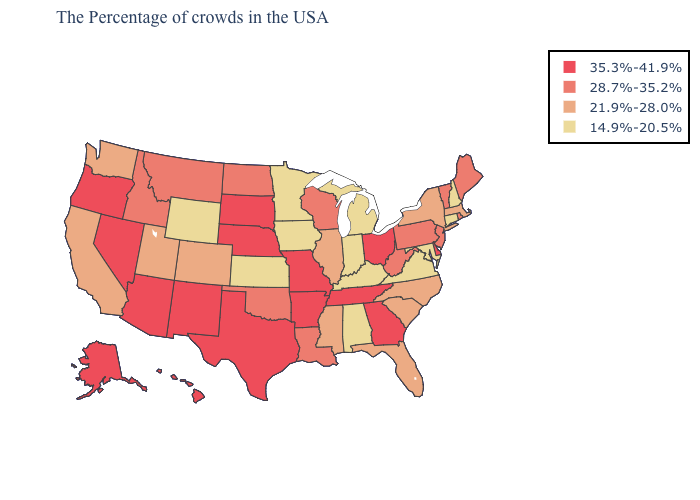Does Hawaii have the lowest value in the USA?
Write a very short answer. No. What is the value of Oklahoma?
Short answer required. 28.7%-35.2%. Does the first symbol in the legend represent the smallest category?
Concise answer only. No. What is the highest value in the USA?
Quick response, please. 35.3%-41.9%. Does Virginia have the lowest value in the USA?
Answer briefly. Yes. Among the states that border West Virginia , does Ohio have the highest value?
Short answer required. Yes. Does Wyoming have the lowest value in the West?
Keep it brief. Yes. Among the states that border South Carolina , does North Carolina have the lowest value?
Write a very short answer. Yes. What is the highest value in the USA?
Be succinct. 35.3%-41.9%. What is the highest value in the USA?
Be succinct. 35.3%-41.9%. Name the states that have a value in the range 14.9%-20.5%?
Give a very brief answer. New Hampshire, Connecticut, Maryland, Virginia, Michigan, Kentucky, Indiana, Alabama, Minnesota, Iowa, Kansas, Wyoming. How many symbols are there in the legend?
Answer briefly. 4. Which states hav the highest value in the MidWest?
Write a very short answer. Ohio, Missouri, Nebraska, South Dakota. Name the states that have a value in the range 35.3%-41.9%?
Keep it brief. Delaware, Ohio, Georgia, Tennessee, Missouri, Arkansas, Nebraska, Texas, South Dakota, New Mexico, Arizona, Nevada, Oregon, Alaska, Hawaii. What is the lowest value in the West?
Quick response, please. 14.9%-20.5%. 